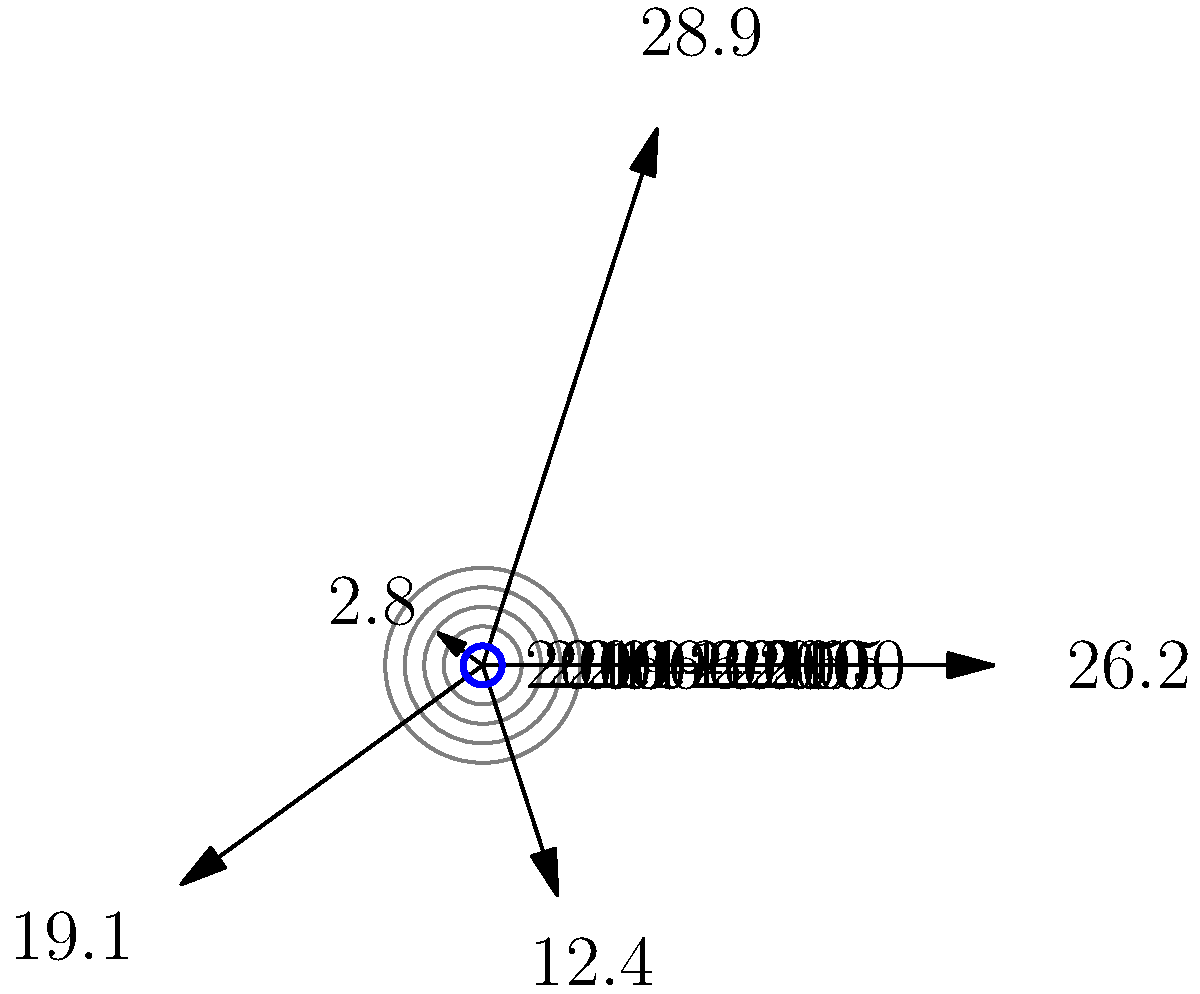Based on the polar plot representing Microsoft's acquisition history, which period saw the most significant increase in acquisition spending compared to the previous period, potentially indicating a shift in Microsoft's strategy? To answer this question, we need to analyze the data presented in the polar plot:

1. The plot shows Microsoft's acquisition spending over five 5-year periods from 1996 to 2020.
2. The values represent the total spending in billions of dollars for each period:
   - 1996-2000: $12.4 billion
   - 2001-2005: $19.1 billion
   - 2006-2010: $2.8 billion
   - 2011-2015: $28.9 billion
   - 2016-2020: $26.2 billion

3. To identify the most significant increase, we need to calculate the difference between each period and its predecessor:
   - 2001-2005 vs 1996-2000: $19.1B - $12.4B = $6.7B increase
   - 2006-2010 vs 2001-2005: $2.8B - $19.1B = $-16.3B decrease
   - 2011-2015 vs 2006-2010: $28.9B - $2.8B = $26.1B increase
   - 2016-2020 vs 2011-2015: $26.2B - $28.9B = $-2.7B decrease

4. The largest increase is between 2006-2010 and 2011-2015, with a $26.1 billion jump in acquisition spending.

This significant increase suggests a major shift in Microsoft's acquisition strategy during the 2011-2015 period, possibly reflecting a change in leadership or a response to market dynamics.
Answer: 2011-2015 